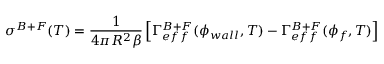<formula> <loc_0><loc_0><loc_500><loc_500>\sigma ^ { B + F } ( T ) = \frac { 1 } { 4 \pi R ^ { 2 } \beta } \left [ \Gamma _ { e f f } ^ { B + F } ( \phi _ { w a l l } , T ) - \Gamma _ { e f f } ^ { B + F } ( \phi _ { f } , T ) \right ]</formula> 